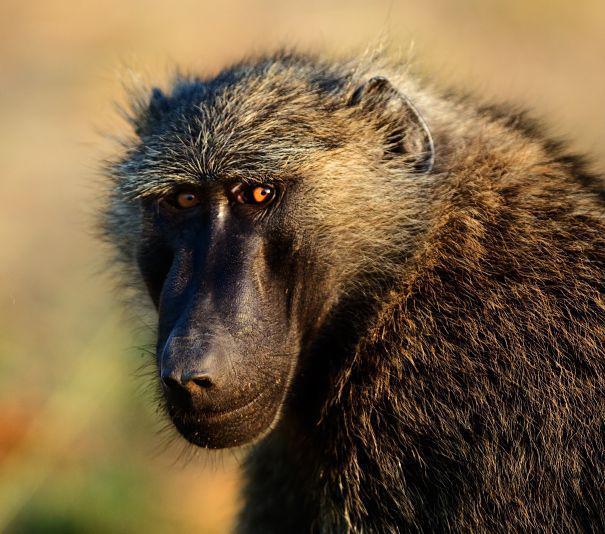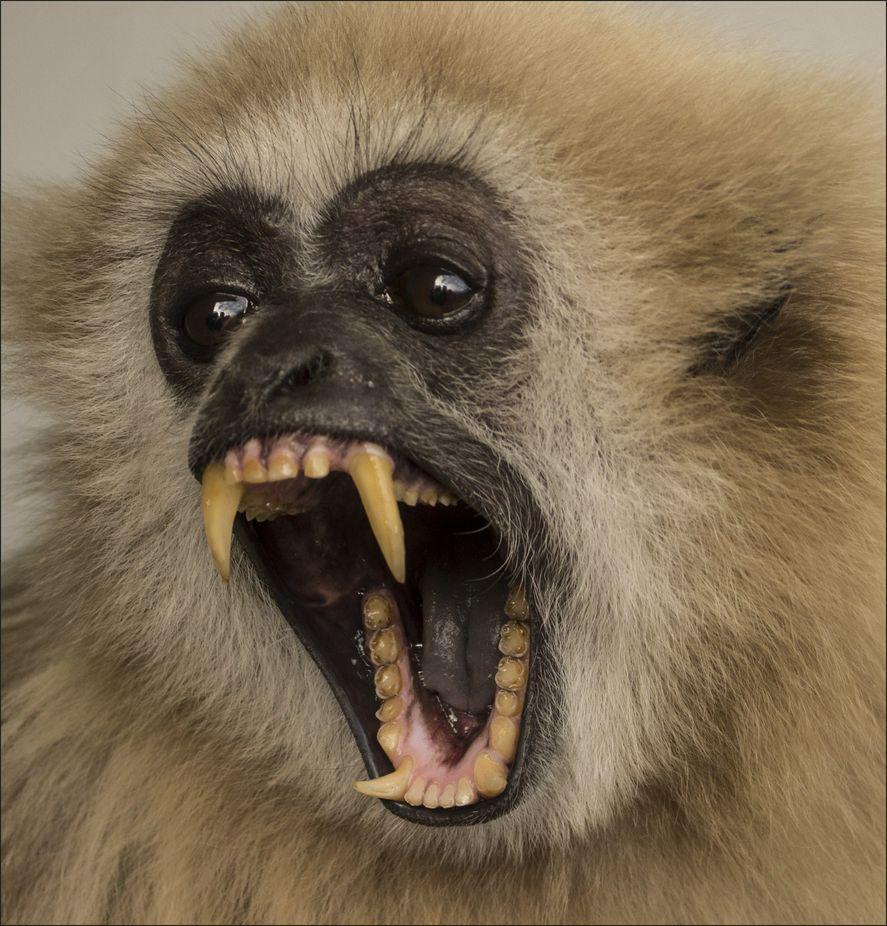The first image is the image on the left, the second image is the image on the right. Considering the images on both sides, is "In one of the images, the animal's mouth is open as it bears its teeth" valid? Answer yes or no. Yes. 